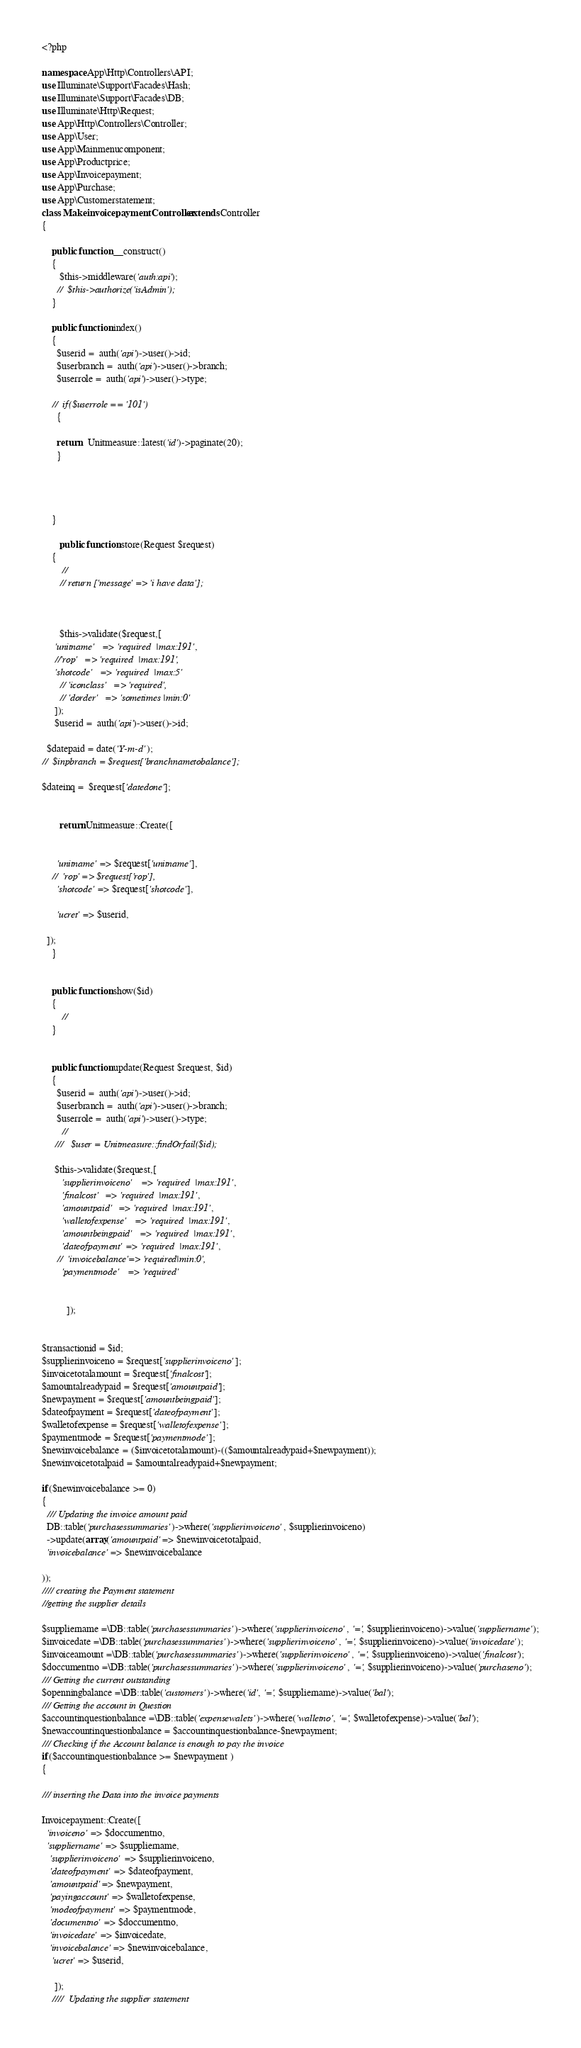<code> <loc_0><loc_0><loc_500><loc_500><_PHP_><?php

namespace App\Http\Controllers\API;
use Illuminate\Support\Facades\Hash;
use Illuminate\Support\Facades\DB;
use Illuminate\Http\Request;
use App\Http\Controllers\Controller;
use App\User;
use App\Mainmenucomponent;
use App\Productprice;
use App\Invoicepayment;
use App\Purchase;
use App\Customerstatement;
class MakeinvoicepaymentController extends Controller
{
    
    public function __construct()
    {
       $this->middleware('auth:api');
      //  $this->authorize('isAdmin'); 
    }

    public function index()
    {
      $userid =  auth('api')->user()->id;
      $userbranch =  auth('api')->user()->branch;
      $userrole =  auth('api')->user()->type;

    //  if($userrole == '101')
      {
    
      return   Unitmeasure::latest('id')->paginate(20);
      }


    
      
    }

       public function store(Request $request)
    {
        //
       // return ['message' => 'i have data'];



       $this->validate($request,[
     'unitname'   => 'required  |max:191',
     //'rop'   => 'required  |max:191',
     'shotcode'   => 'required  |max:5'
       // 'iconclass'   => 'required',
       // 'dorder'   => 'sometimes |min:0'
     ]);
     $userid =  auth('api')->user()->id;

  $datepaid = date('Y-m-d');
//  $inpbranch = $request['branchnametobalance'];

$dateinq =  $request['datedone'];


       return Unitmeasure::Create([
    

      'unitname' => $request['unitname'],
    //  'rop' => $request['rop'],
      'shotcode' => $request['shotcode'],
     
      'ucret' => $userid,
    
  ]);
    }

    
    public function show($id)
    {
        //
    }
   
   
    public function update(Request $request, $id)
    {
      $userid =  auth('api')->user()->id;
      $userbranch =  auth('api')->user()->branch;
      $userrole =  auth('api')->user()->type;
        //
     ///   $user = Unitmeasure::findOrfail($id);

     $this->validate($request,[
        'supplierinvoiceno'   => 'required  |max:191',
        'finalcost'   => 'required  |max:191',
        'amountpaid'   => 'required  |max:191',
        'walletofexpense'   => 'required  |max:191',
        'amountbeingpaid'   => 'required  |max:191',
        'dateofpayment' => 'required  |max:191',
      //  'invoicebalance'=> 'required|min:0',
        'paymentmode'   => 'required'
        
      
          ]);
      

$transactionid = $id;
$supplierinvoiceno = $request['supplierinvoiceno'];
$invoicetotalamount = $request['finalcost'];
$amountalreadypaid = $request['amountpaid'];
$newpayment = $request['amountbeingpaid'];
$dateofpayment = $request['dateofpayment'];
$walletofexpense = $request['walletofexpense'];
$paymentmode = $request['paymentmode'];
$newinvoicebalance = ($invoicetotalamount)-(($amountalreadypaid+$newpayment)); 
$newinvoicetotalpaid = $amountalreadypaid+$newpayment;

if($newinvoicebalance >= 0)
{
  /// Updating the invoice amount paid
  DB::table('purchasessummaries')->where('supplierinvoiceno', $supplierinvoiceno)
  ->update(array('amountpaid' => $newinvoicetotalpaid,
  'invoicebalance' => $newinvoicebalance

));
//// creating the Payment statement 
//getting the supplier details

$suppliername =\DB::table('purchasessummaries')->where('supplierinvoiceno', '=', $supplierinvoiceno)->value('suppliername');
$invoicedate =\DB::table('purchasessummaries')->where('supplierinvoiceno', '=', $supplierinvoiceno)->value('invoicedate');
$invoiceamount =\DB::table('purchasessummaries')->where('supplierinvoiceno', '=', $supplierinvoiceno)->value('finalcost');
$doccumentno =\DB::table('purchasessummaries')->where('supplierinvoiceno', '=', $supplierinvoiceno)->value('purchaseno');
/// Getting the current outstanding
$openningbalance =\DB::table('customers')->where('id', '=', $suppliername)->value('bal');
/// Getting the account in Question
$accountinquestionbalance =\DB::table('expensewalets')->where('walletno', '=', $walletofexpense)->value('bal');
$newaccountinquestionbalance = $accountinquestionbalance-$newpayment;
/// Checking if the Account balance is enough to pay the invoice
if($accountinquestionbalance >= $newpayment )
{

/// inserting the Data into the invoice payments

Invoicepayment::Create([
  'invoiceno' => $doccumentno,
  'suppliername' => $suppliername,
   'supplierinvoiceno' => $supplierinvoiceno,
   'dateofpayment' => $dateofpayment,
   'amountpaid' => $newpayment,
   'payingaccount' => $walletofexpense,
   'modeofpayment' => $paymentmode,
   'documentno' => $doccumentno,
   'invoicedate' => $invoicedate,
   'invoicebalance' => $newinvoicebalance,
    'ucret' => $userid,
       
     ]);
    ////  Updating the supplier statement</code> 